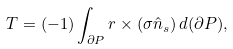Convert formula to latex. <formula><loc_0><loc_0><loc_500><loc_500>T = ( - 1 ) \int _ { \partial P } r \times ( \sigma \hat { n } _ { s } ) \, d ( \partial P ) ,</formula> 